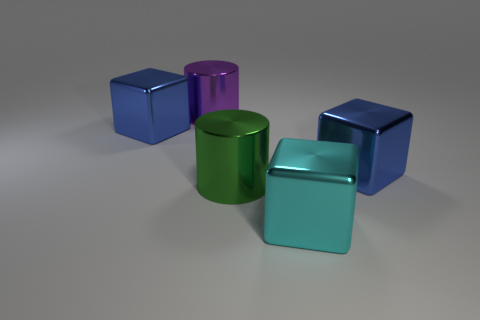Add 5 shiny cylinders. How many objects exist? 10 Subtract all blocks. How many objects are left? 2 Subtract 1 cyan blocks. How many objects are left? 4 Subtract all brown rubber cylinders. Subtract all big blue blocks. How many objects are left? 3 Add 4 cylinders. How many cylinders are left? 6 Add 4 big gray objects. How many big gray objects exist? 4 